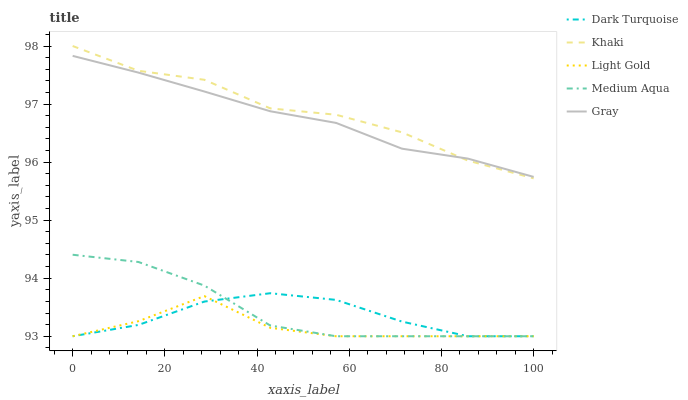Does Light Gold have the minimum area under the curve?
Answer yes or no. Yes. Does Khaki have the maximum area under the curve?
Answer yes or no. Yes. Does Dark Turquoise have the minimum area under the curve?
Answer yes or no. No. Does Dark Turquoise have the maximum area under the curve?
Answer yes or no. No. Is Gray the smoothest?
Answer yes or no. Yes. Is Light Gold the roughest?
Answer yes or no. Yes. Is Dark Turquoise the smoothest?
Answer yes or no. No. Is Dark Turquoise the roughest?
Answer yes or no. No. Does Khaki have the lowest value?
Answer yes or no. No. Does Khaki have the highest value?
Answer yes or no. Yes. Does Dark Turquoise have the highest value?
Answer yes or no. No. Is Medium Aqua less than Gray?
Answer yes or no. Yes. Is Gray greater than Light Gold?
Answer yes or no. Yes. Does Medium Aqua intersect Dark Turquoise?
Answer yes or no. Yes. Is Medium Aqua less than Dark Turquoise?
Answer yes or no. No. Is Medium Aqua greater than Dark Turquoise?
Answer yes or no. No. Does Medium Aqua intersect Gray?
Answer yes or no. No. 